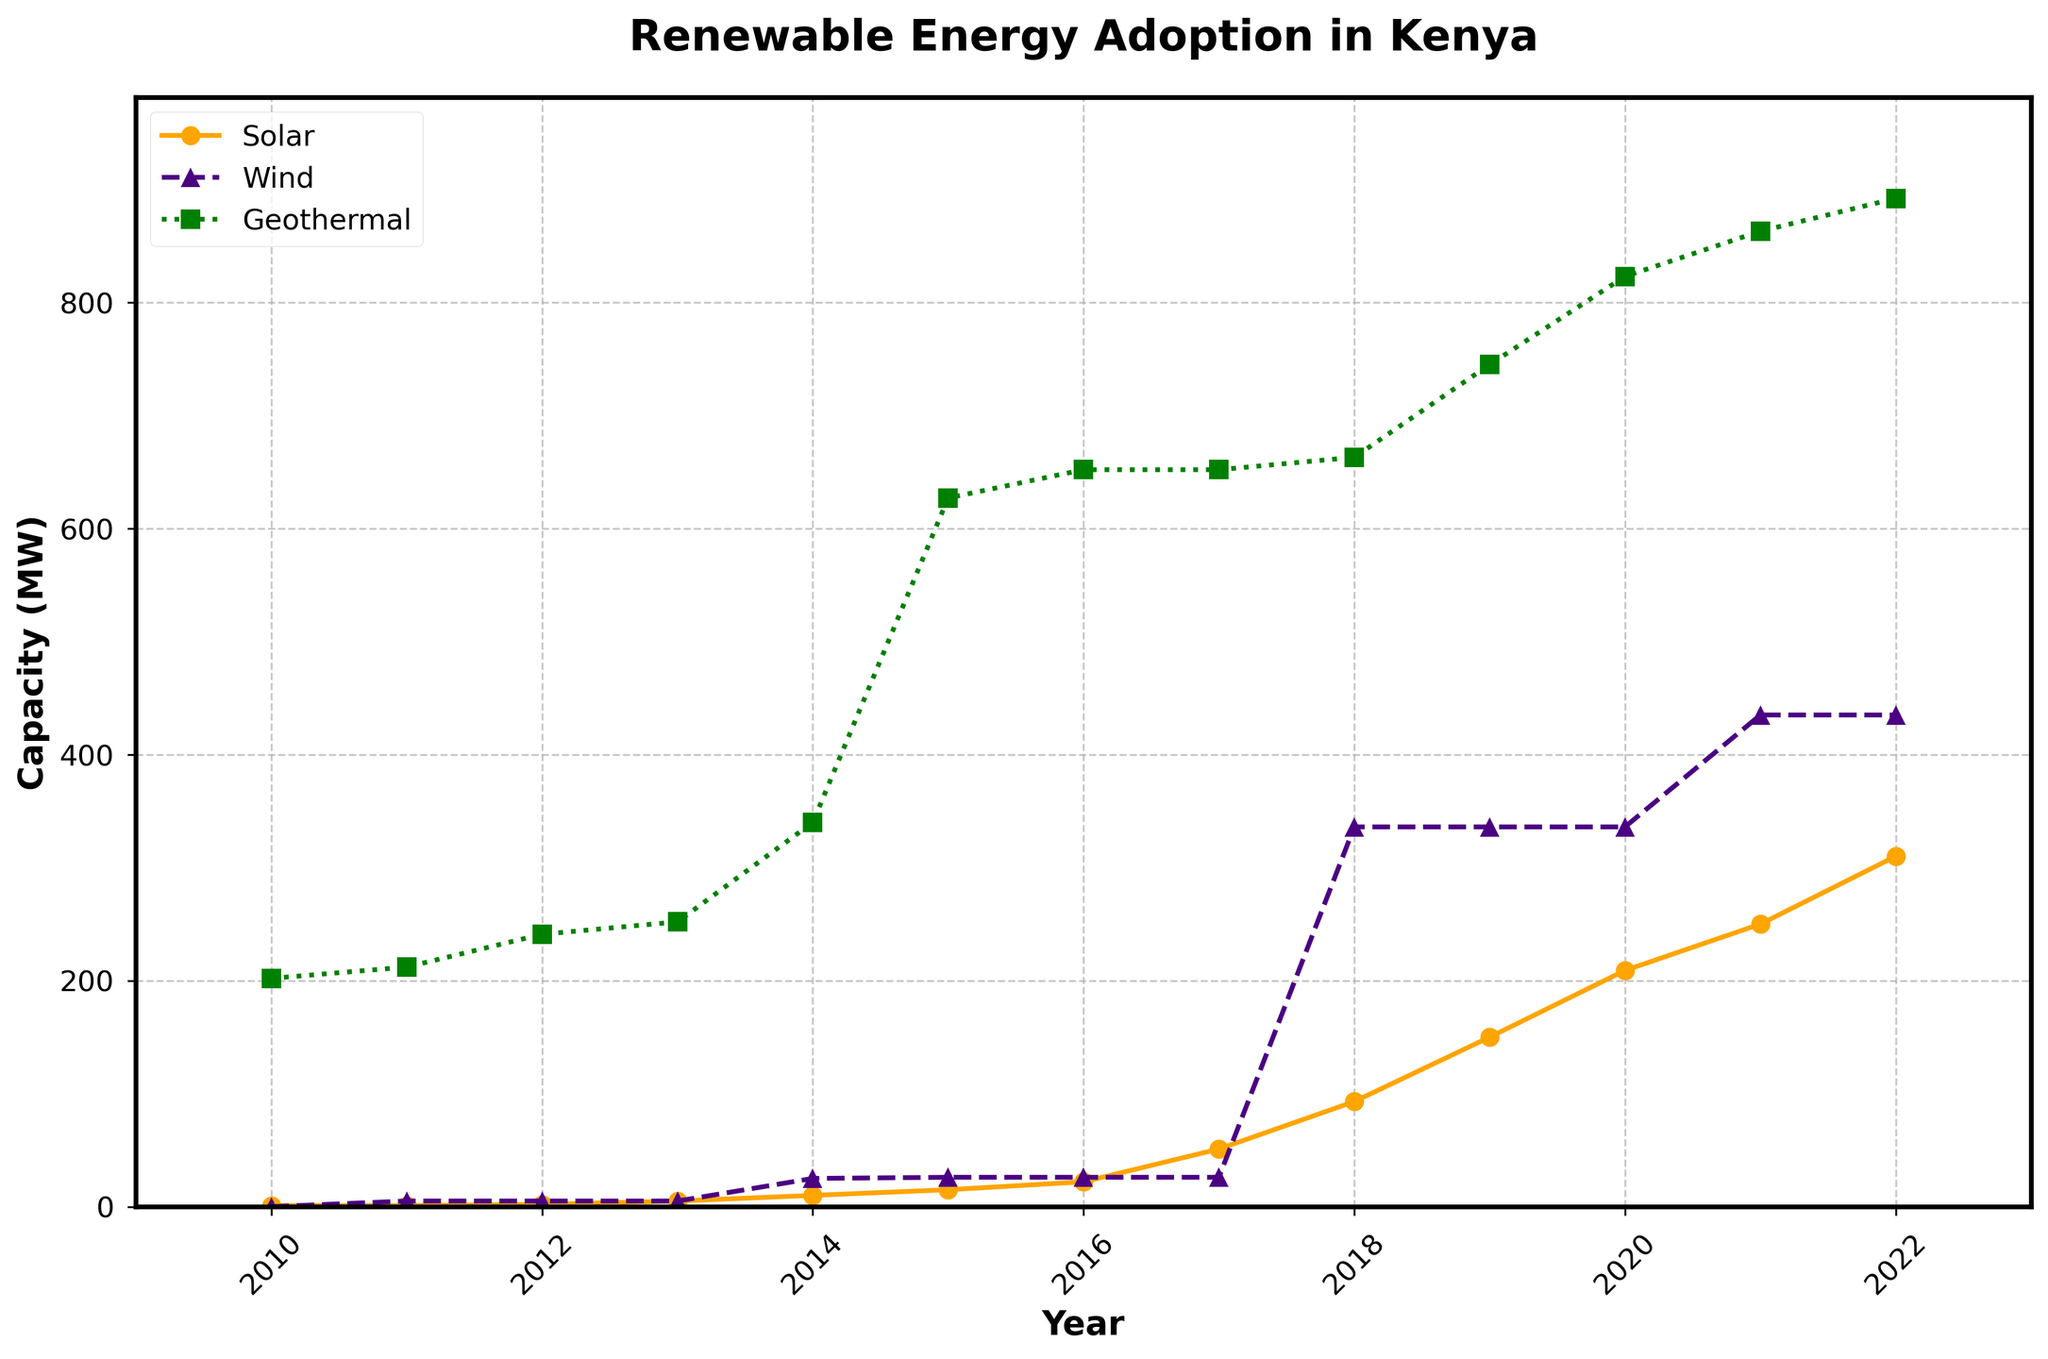What is the average solar capacity between 2010 and 2022? To find the average solar capacity, sum the solar capacities for each year from 2010 to 2022 and divide by the number of years. (1+1+2+5+10+15+22+51+93+150+209+250+310) / 13 = 111.23
Answer: 111.23 MW In which year did wind energy experience the largest increase? Compare the wind capacity year-over-year and identify the year with the largest increase. The biggest change occurs from 2017 to 2018, increasing from 26 MW to 336 MW.
Answer: 2018 How much did geothermal capacity grow from 2010 to 2022? Subtract the geothermal capacity in 2010 from that in 2022: 892 MW (2022) - 202 MW (2010) = 690 MW
Answer: 690 MW Which renewable energy source had the highest capacity in 2022? Compare the capacities of solar, wind, and geothermal in 2022. Geothermal has the highest capacity at 892 MW.
Answer: Geothermal Did solar capacity surpass wind capacity before 2018? Examine the plot and note the years to see if solar capacity exceeded wind before 2018. Solar capacity only surpassed wind capacity in 2018.
Answer: No What was the combined capacity of solar and wind energy in 2015? Sum the solar and wind capacities in 2015: 15 MW (solar) + 26 MW (wind) = 41 MW
Answer: 41 MW Which year shows the most balanced capacity between solar, wind, and geothermal energy? Look for the year where the gaps between the capacities of solar, wind, and geothermal are the smallest. In 2014, solar was 10 MW, wind was 25 MW, and geothermal was 340 MW. This is the year with the least disparity, although the capacities are still largely different.
Answer: 2014 Between which years did geothermal energy see the first major increase? Determine the period during which geothermal capacity saw the first significant rise. There was a notable increase between 2013 (252 MW) and 2014 (340 MW).
Answer: 2013-2014 